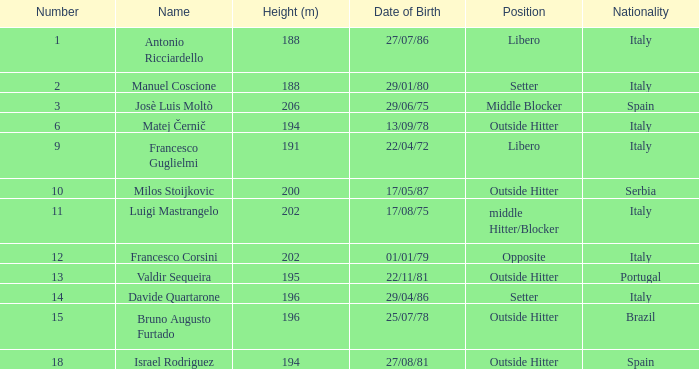Identify the nationality of francesco guglielmi. Italy. 